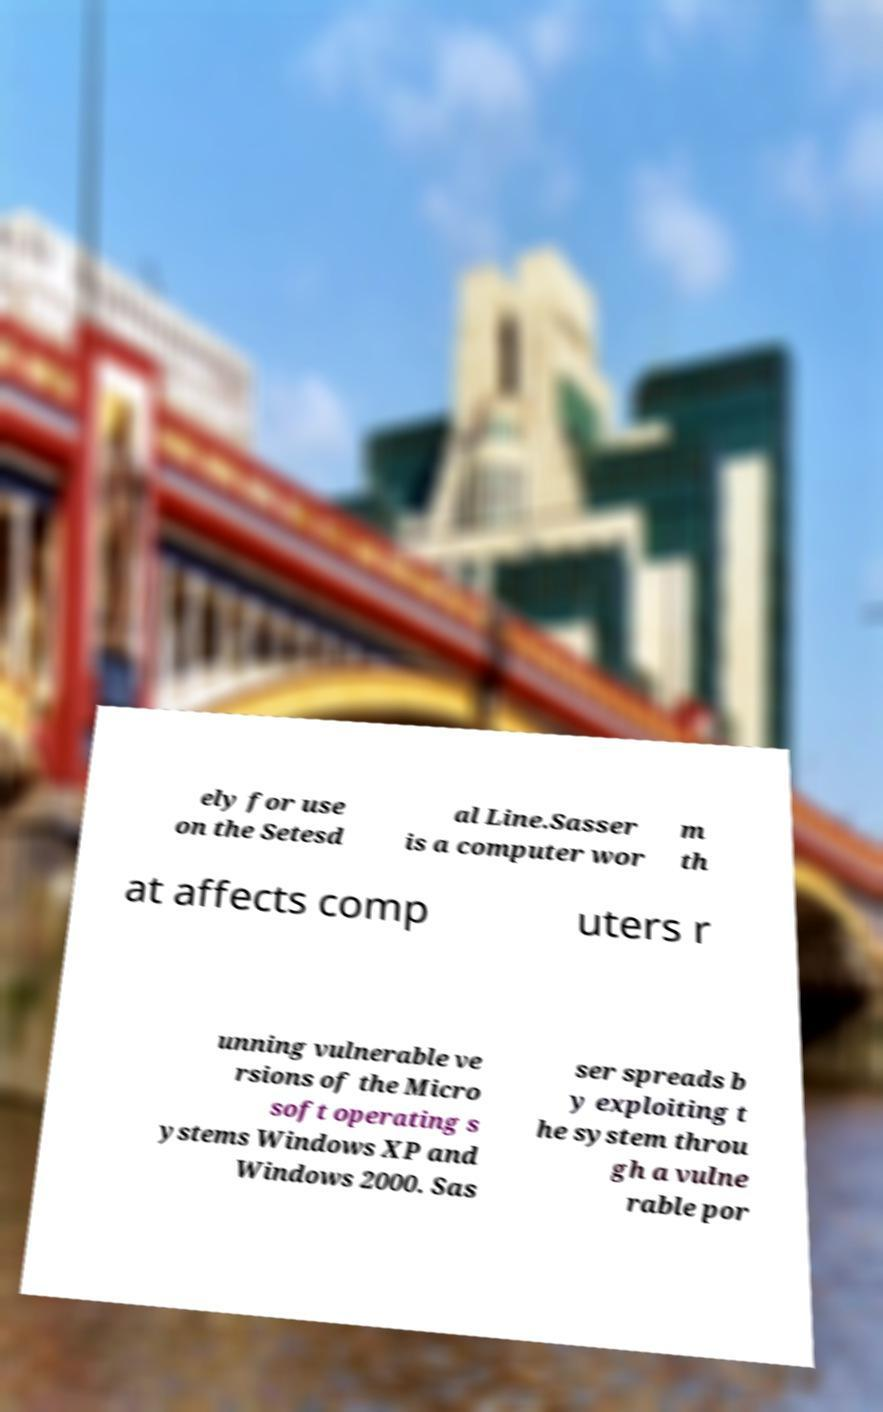For documentation purposes, I need the text within this image transcribed. Could you provide that? ely for use on the Setesd al Line.Sasser is a computer wor m th at affects comp uters r unning vulnerable ve rsions of the Micro soft operating s ystems Windows XP and Windows 2000. Sas ser spreads b y exploiting t he system throu gh a vulne rable por 